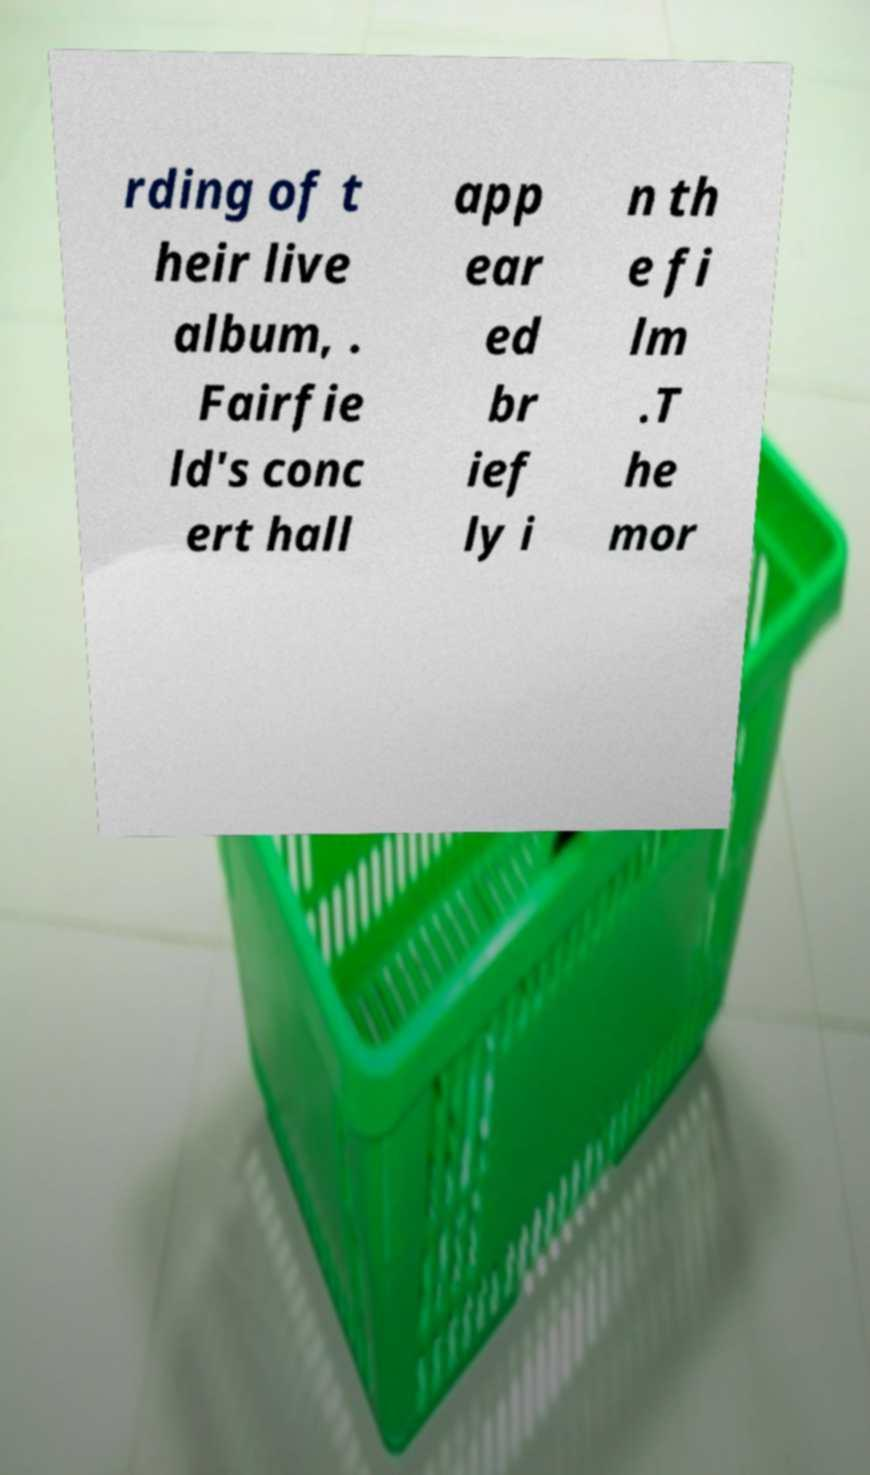What messages or text are displayed in this image? I need them in a readable, typed format. rding of t heir live album, . Fairfie ld's conc ert hall app ear ed br ief ly i n th e fi lm .T he mor 